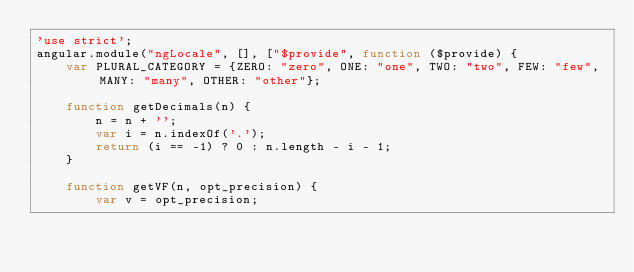<code> <loc_0><loc_0><loc_500><loc_500><_JavaScript_>'use strict';
angular.module("ngLocale", [], ["$provide", function ($provide) {
    var PLURAL_CATEGORY = {ZERO: "zero", ONE: "one", TWO: "two", FEW: "few", MANY: "many", OTHER: "other"};

    function getDecimals(n) {
        n = n + '';
        var i = n.indexOf('.');
        return (i == -1) ? 0 : n.length - i - 1;
    }

    function getVF(n, opt_precision) {
        var v = opt_precision;
</code> 